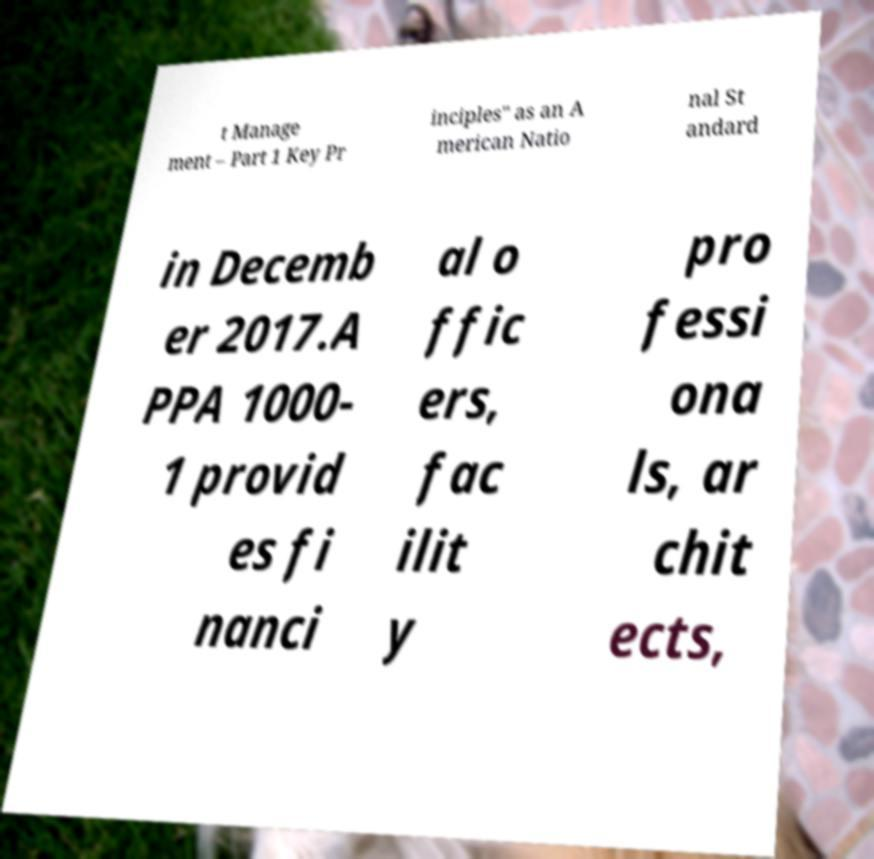I need the written content from this picture converted into text. Can you do that? t Manage ment – Part 1 Key Pr inciples" as an A merican Natio nal St andard in Decemb er 2017.A PPA 1000- 1 provid es fi nanci al o ffic ers, fac ilit y pro fessi ona ls, ar chit ects, 